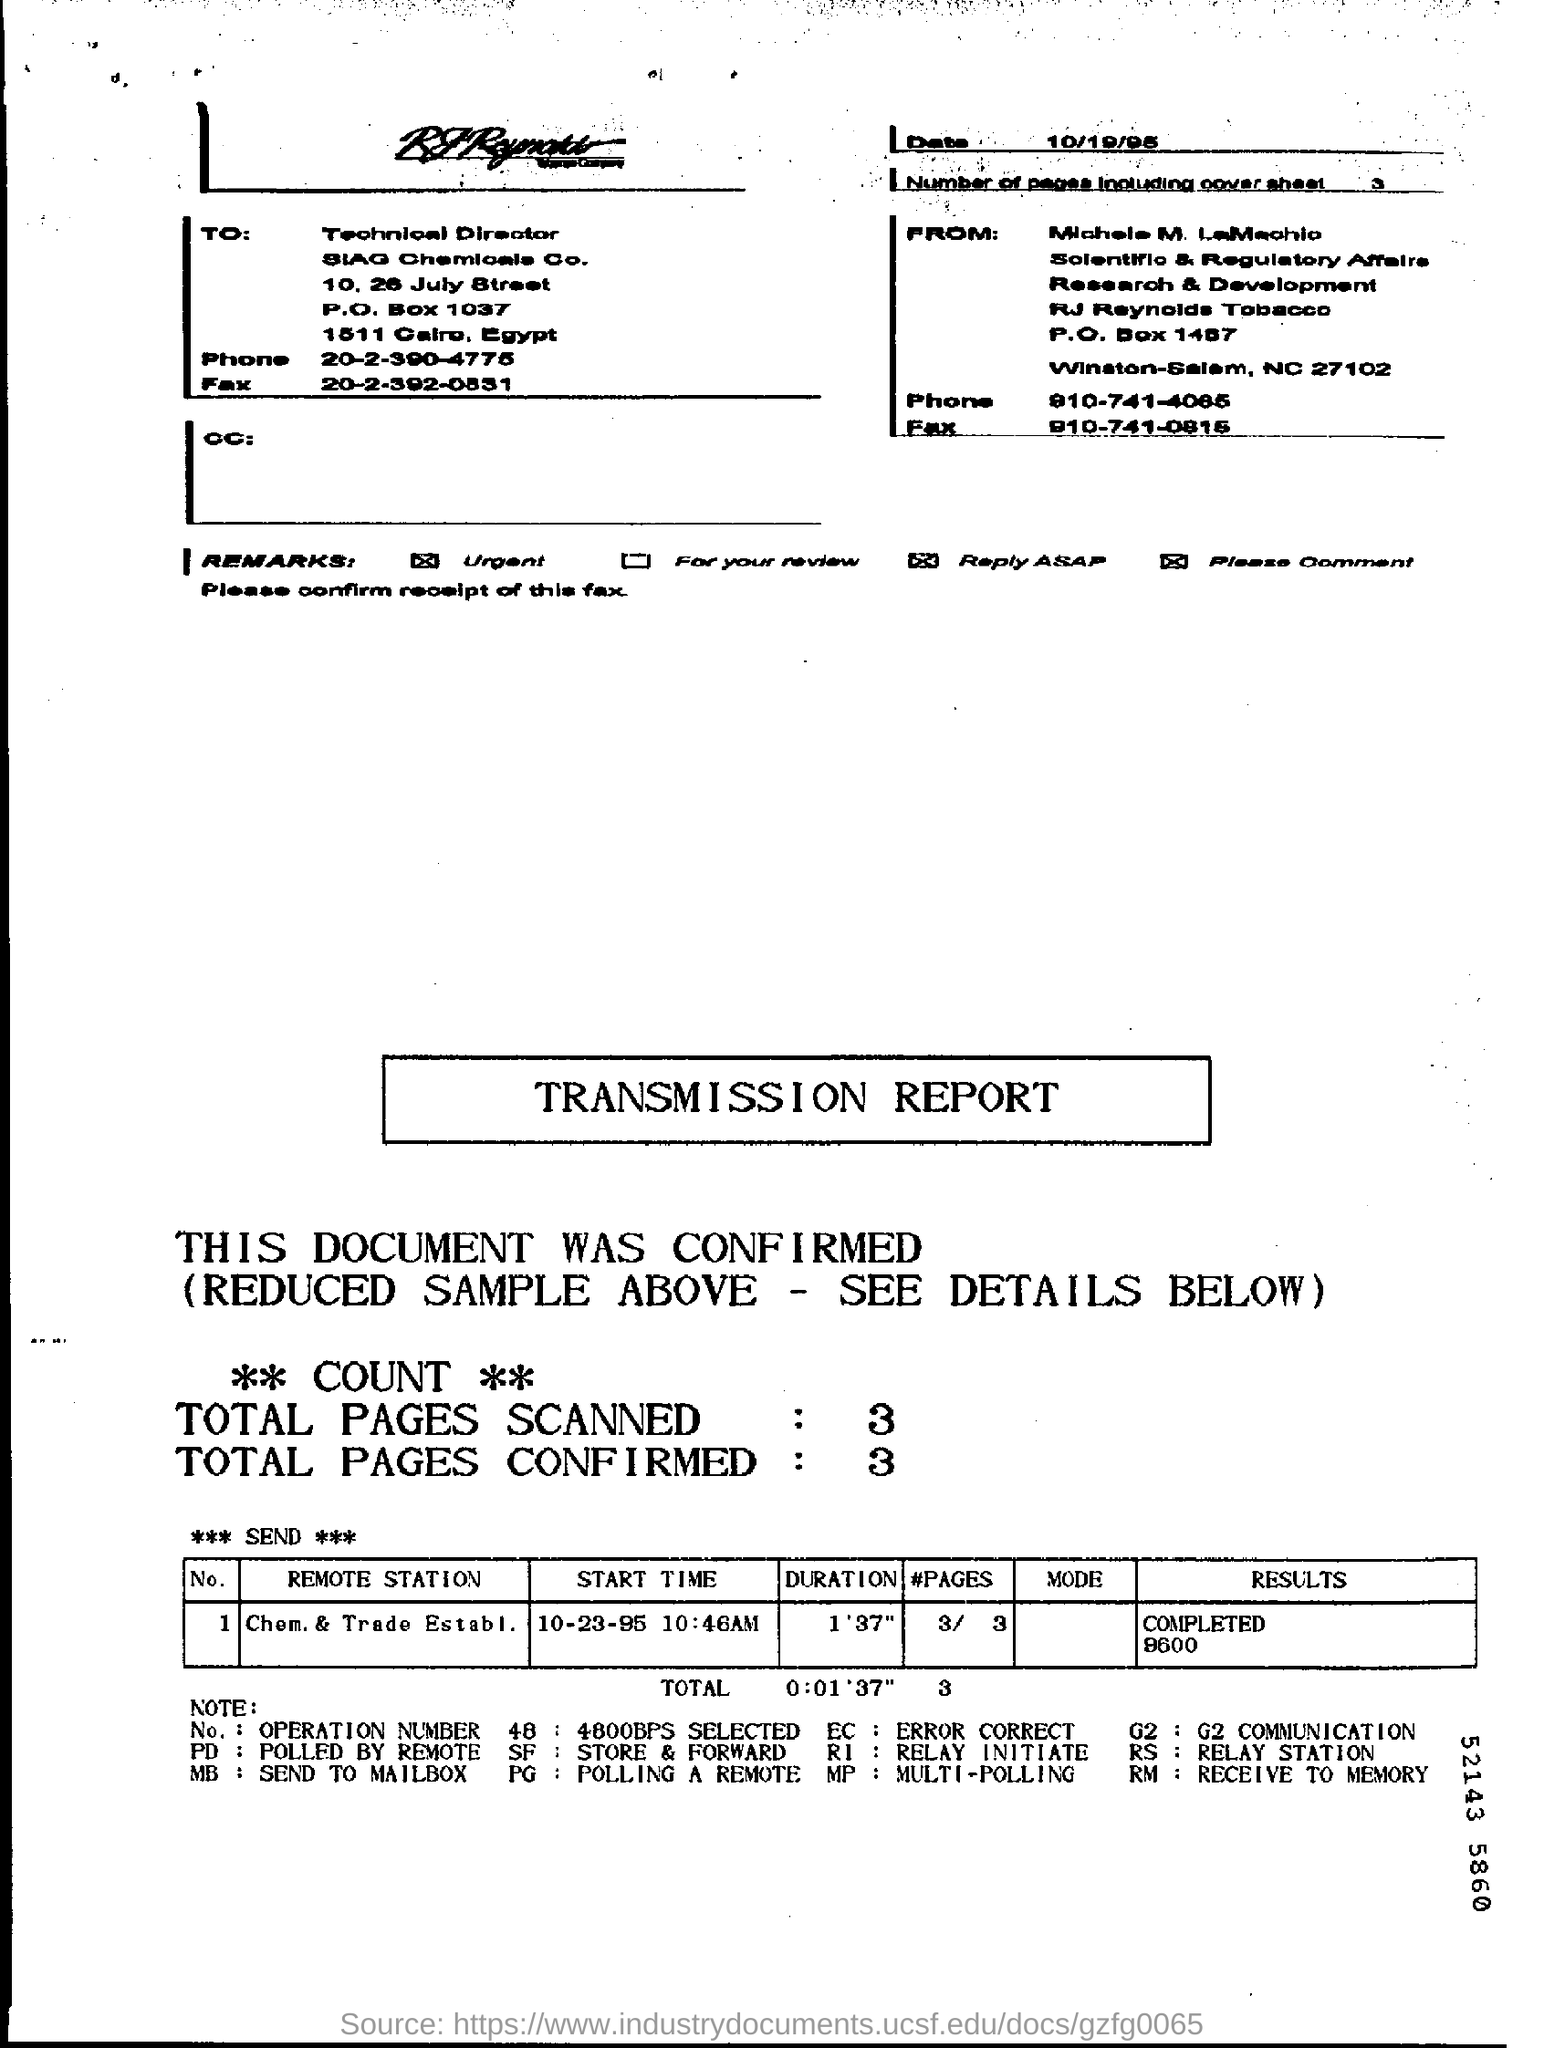Indicate a few pertinent items in this graphic. EC" refers to "Error Correction," a method used to detect and correct errors that may occur during data transmission or storage. This expansion is commonly used in various technologies such as communication systems, data storage systems, and computer systems. The "REMOTE STATION" is a term used to describe the establishment of a chemical and trading business. This report is a transmission report. Please mention the total number of pages scanned, from 3.. The expansion of RI is underway, with relay initiate... leading the way. 